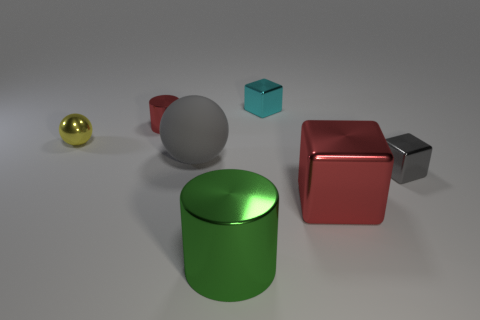There is a big thing on the right side of the big green metal cylinder; what material is it?
Provide a succinct answer. Metal. Are there any small metallic cylinders in front of the small red shiny thing?
Your answer should be very brief. No. The cyan thing has what shape?
Offer a terse response. Cube. What number of things are shiny cylinders in front of the large gray object or big metallic cylinders?
Provide a short and direct response. 1. How many other things are there of the same color as the small metal sphere?
Make the answer very short. 0. There is a rubber ball; does it have the same color as the cube right of the red cube?
Ensure brevity in your answer.  Yes. There is another object that is the same shape as the big matte thing; what is its color?
Provide a succinct answer. Yellow. Is the small gray block made of the same material as the block behind the small yellow metallic sphere?
Make the answer very short. Yes. What color is the big ball?
Offer a terse response. Gray. There is a block that is to the left of the red object that is to the right of the metallic cylinder in front of the large red cube; what color is it?
Provide a succinct answer. Cyan. 